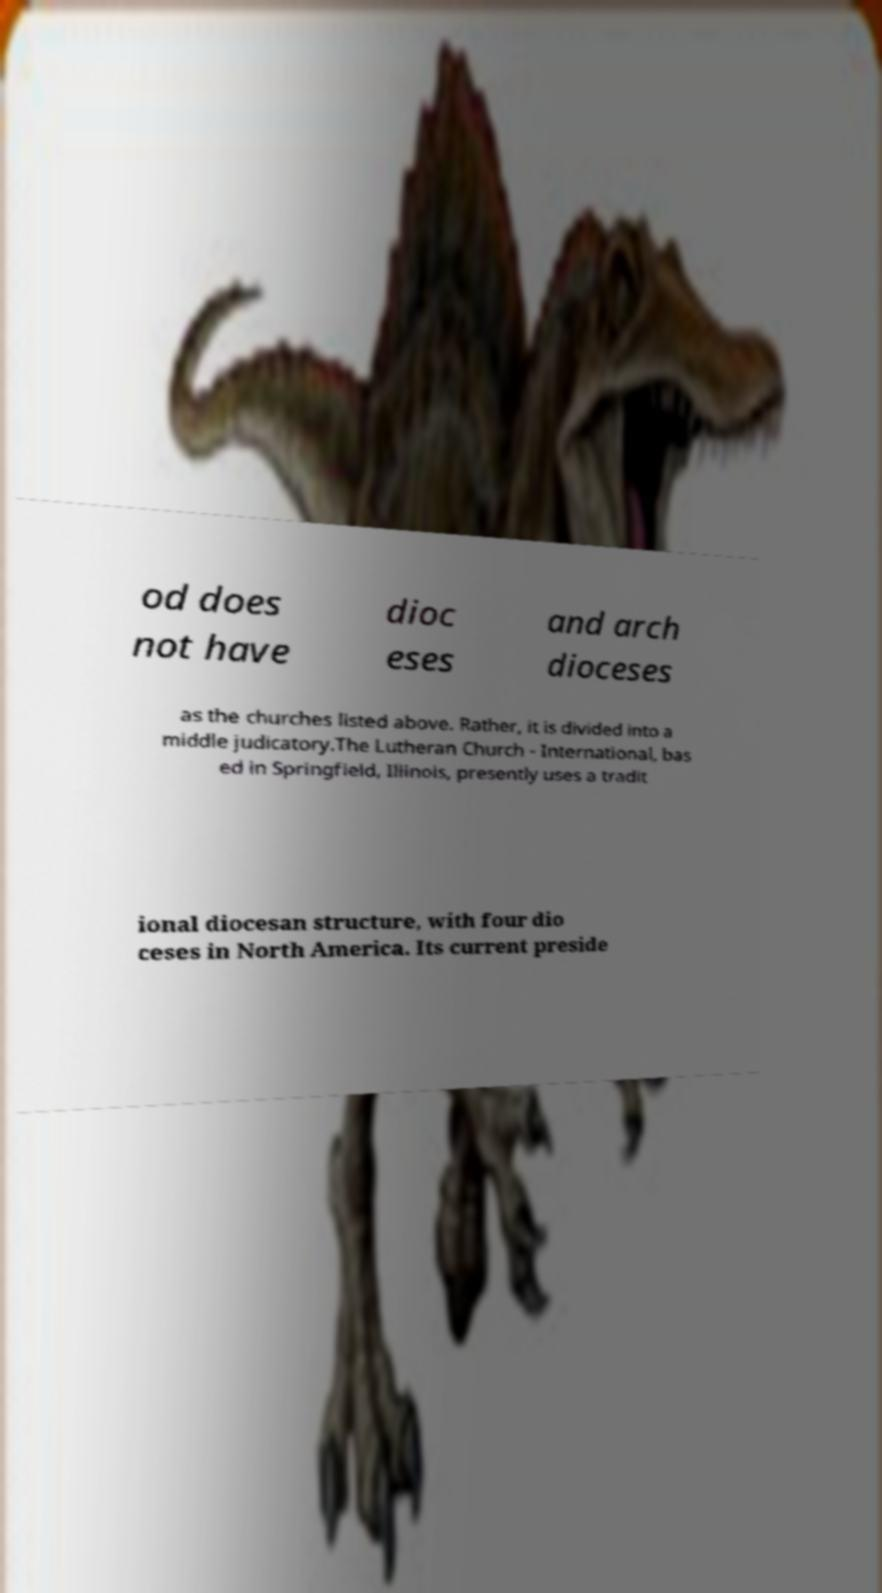Could you assist in decoding the text presented in this image and type it out clearly? od does not have dioc eses and arch dioceses as the churches listed above. Rather, it is divided into a middle judicatory.The Lutheran Church - International, bas ed in Springfield, Illinois, presently uses a tradit ional diocesan structure, with four dio ceses in North America. Its current preside 